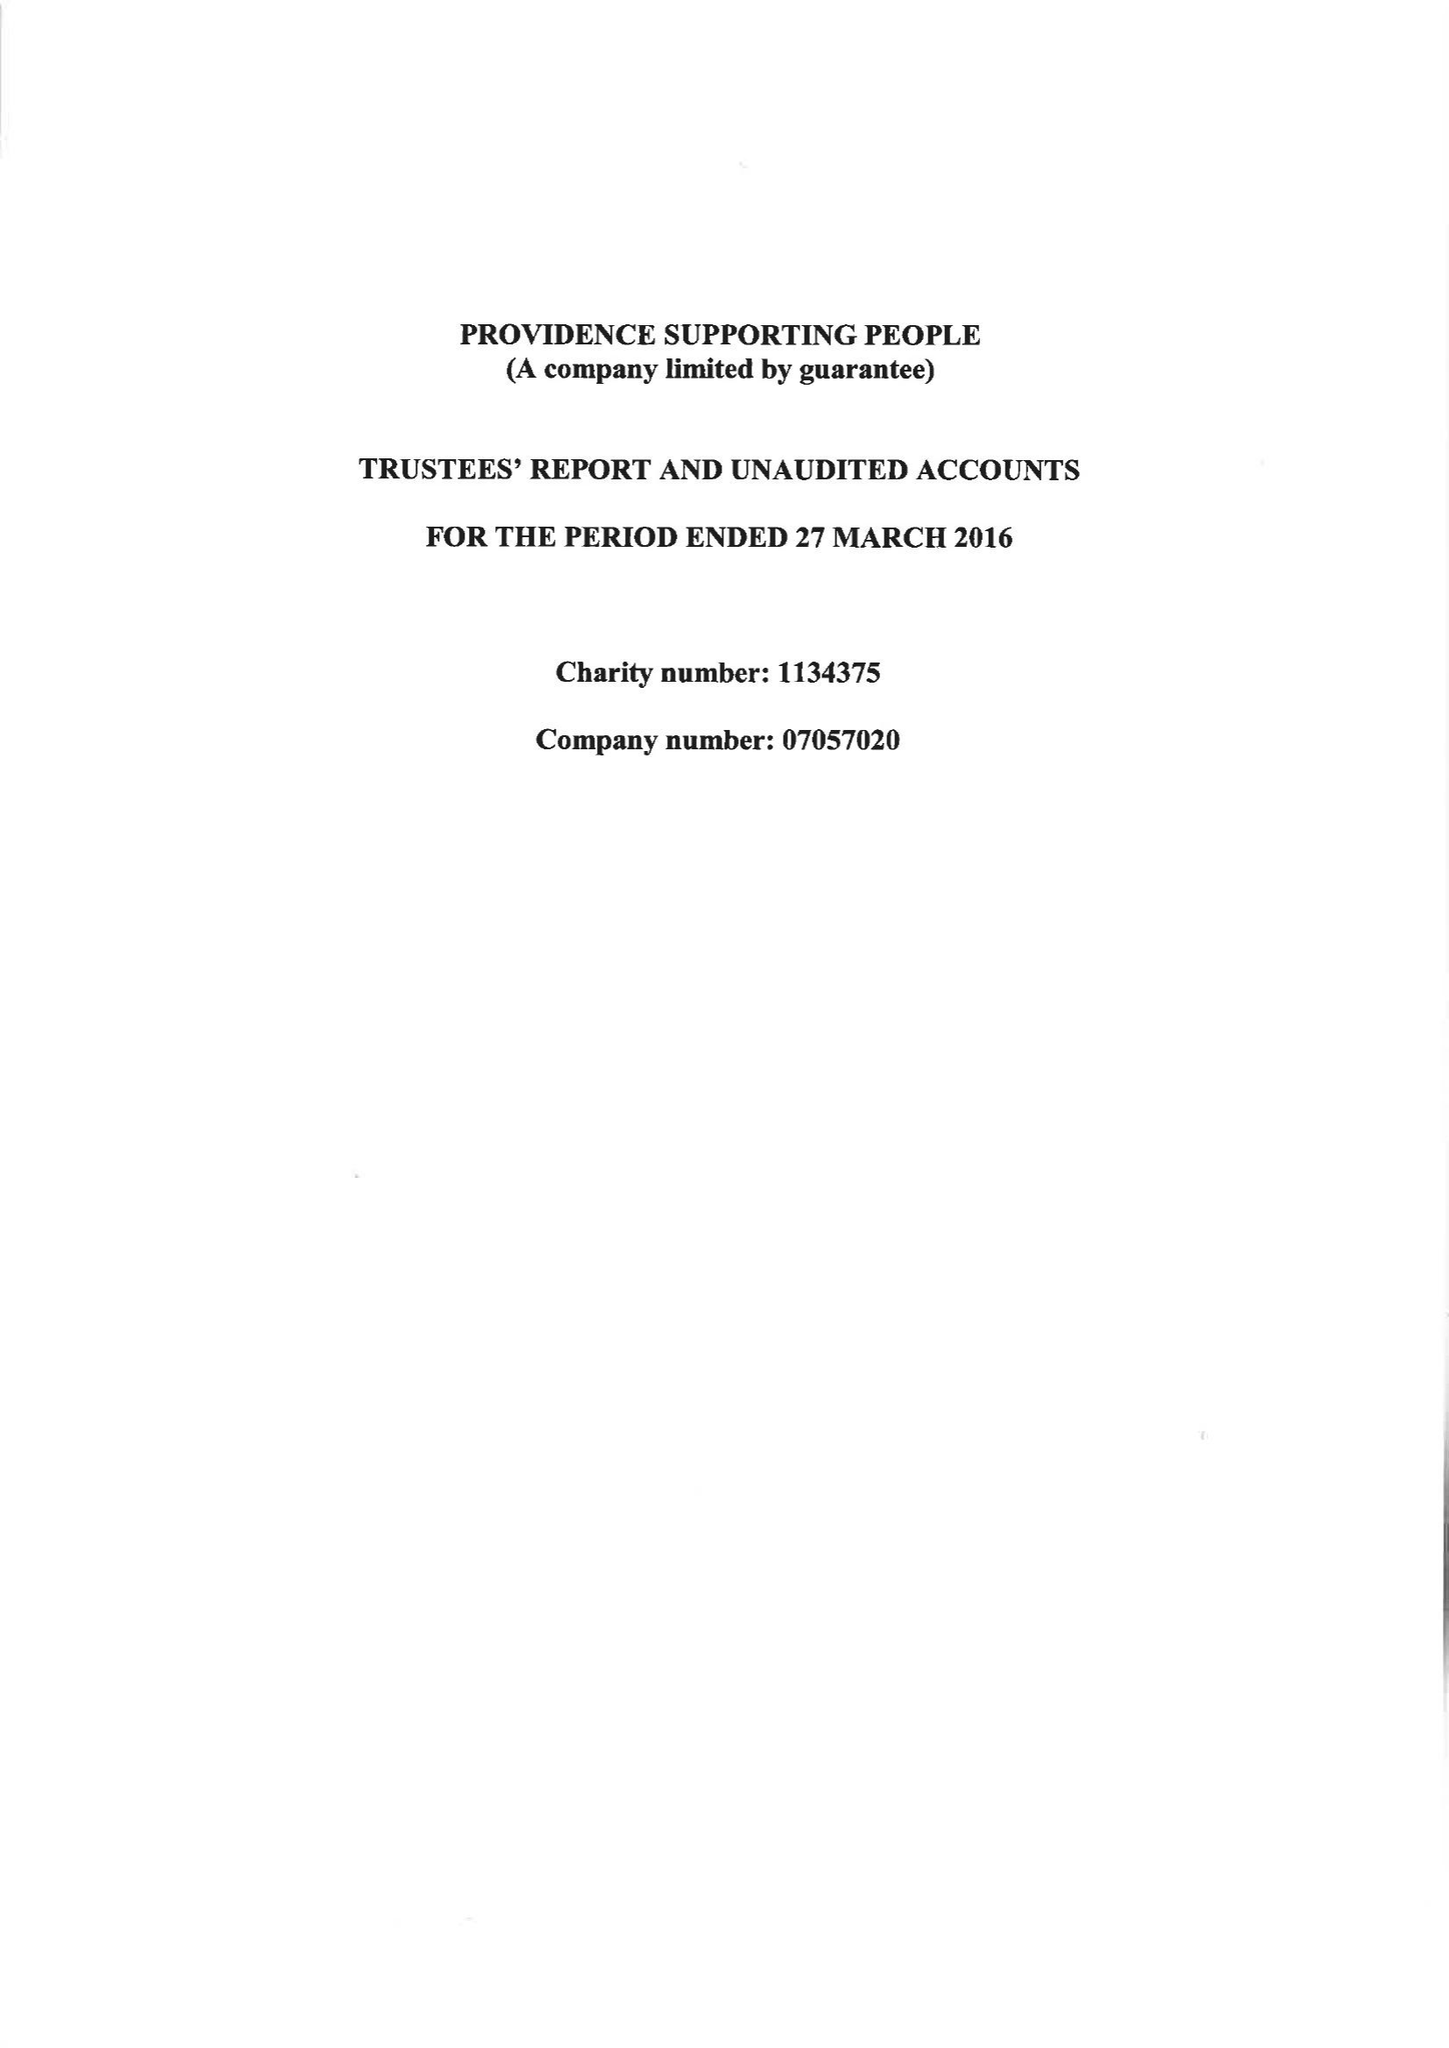What is the value for the address__street_line?
Answer the question using a single word or phrase. 17 CARYSFORT ROAD 